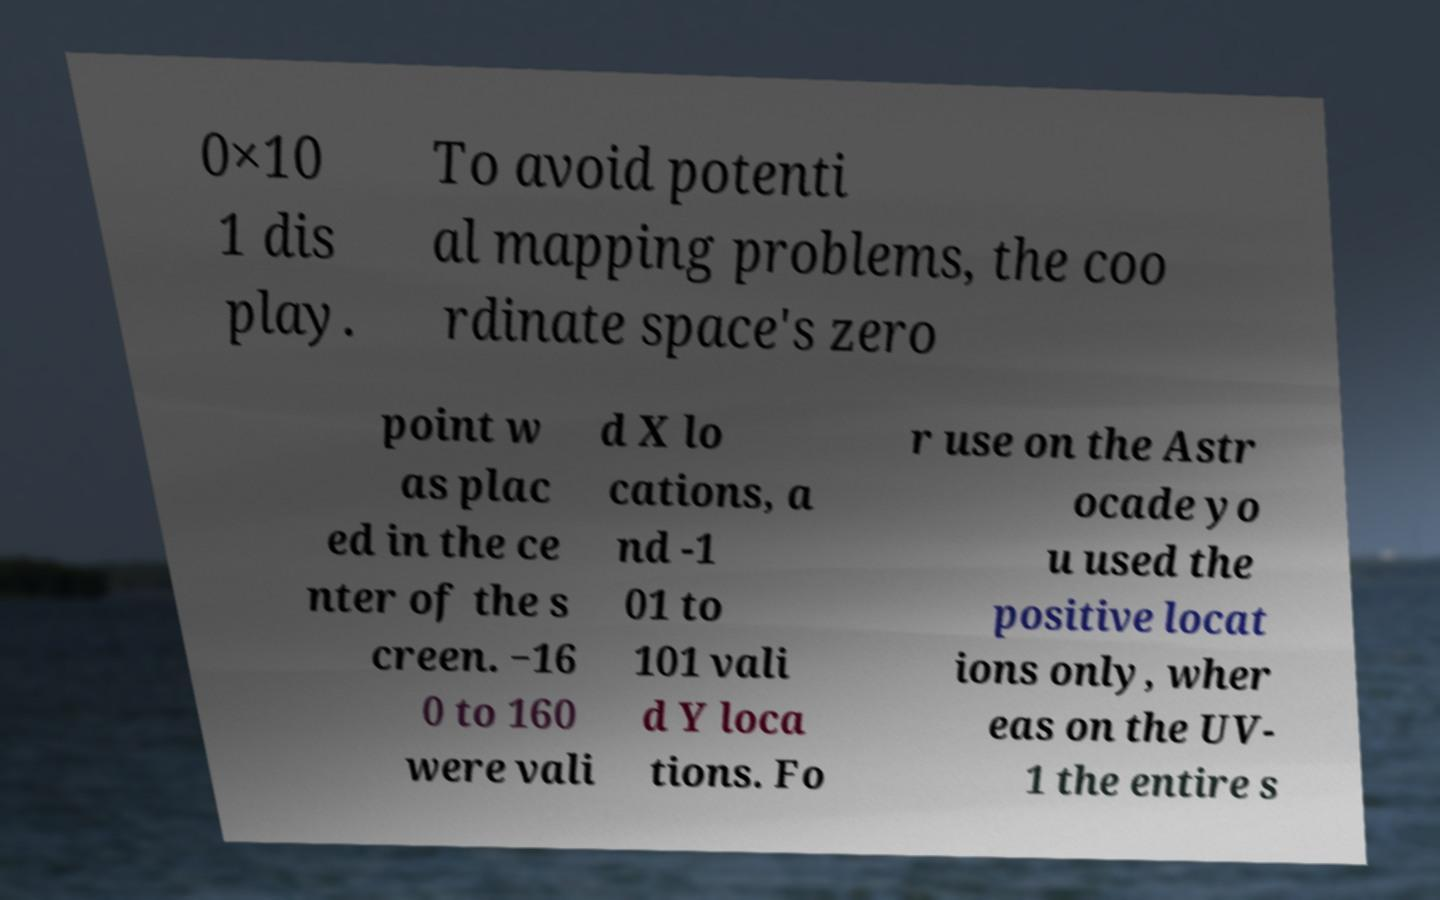What messages or text are displayed in this image? I need them in a readable, typed format. 0×10 1 dis play. To avoid potenti al mapping problems, the coo rdinate space's zero point w as plac ed in the ce nter of the s creen. −16 0 to 160 were vali d X lo cations, a nd -1 01 to 101 vali d Y loca tions. Fo r use on the Astr ocade yo u used the positive locat ions only, wher eas on the UV- 1 the entire s 